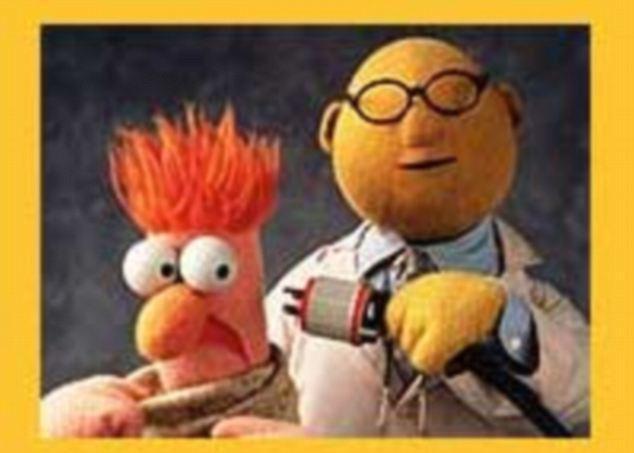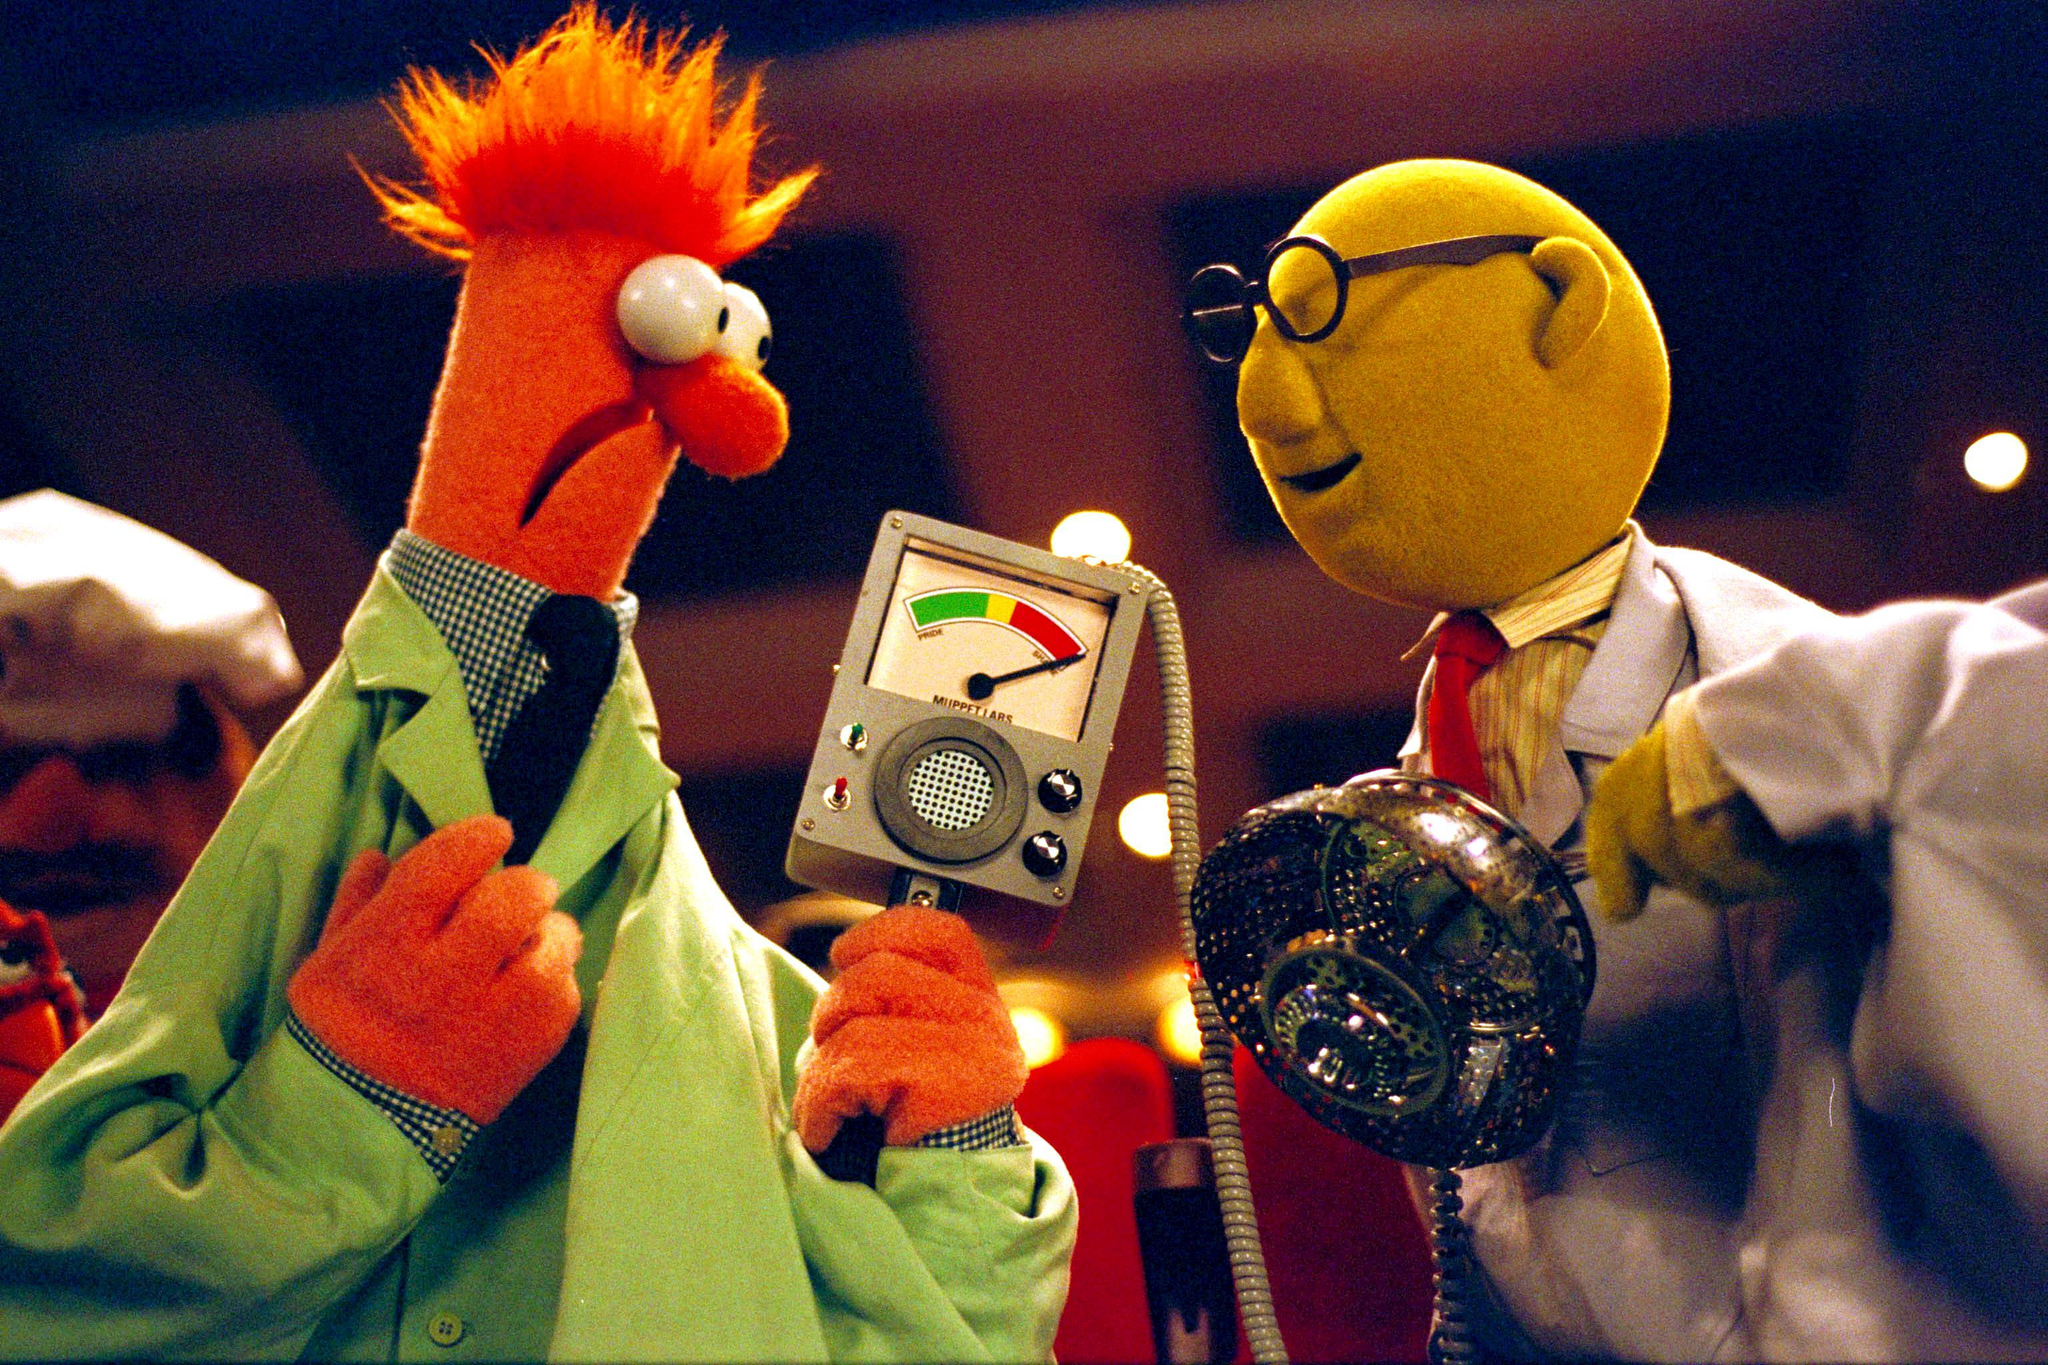The first image is the image on the left, the second image is the image on the right. Evaluate the accuracy of this statement regarding the images: "Each image has the same two muppets without any other muppets.". Is it true? Answer yes or no. Yes. 